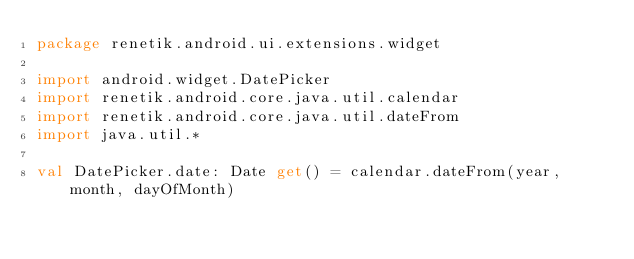Convert code to text. <code><loc_0><loc_0><loc_500><loc_500><_Kotlin_>package renetik.android.ui.extensions.widget

import android.widget.DatePicker
import renetik.android.core.java.util.calendar
import renetik.android.core.java.util.dateFrom
import java.util.*

val DatePicker.date: Date get() = calendar.dateFrom(year, month, dayOfMonth)</code> 